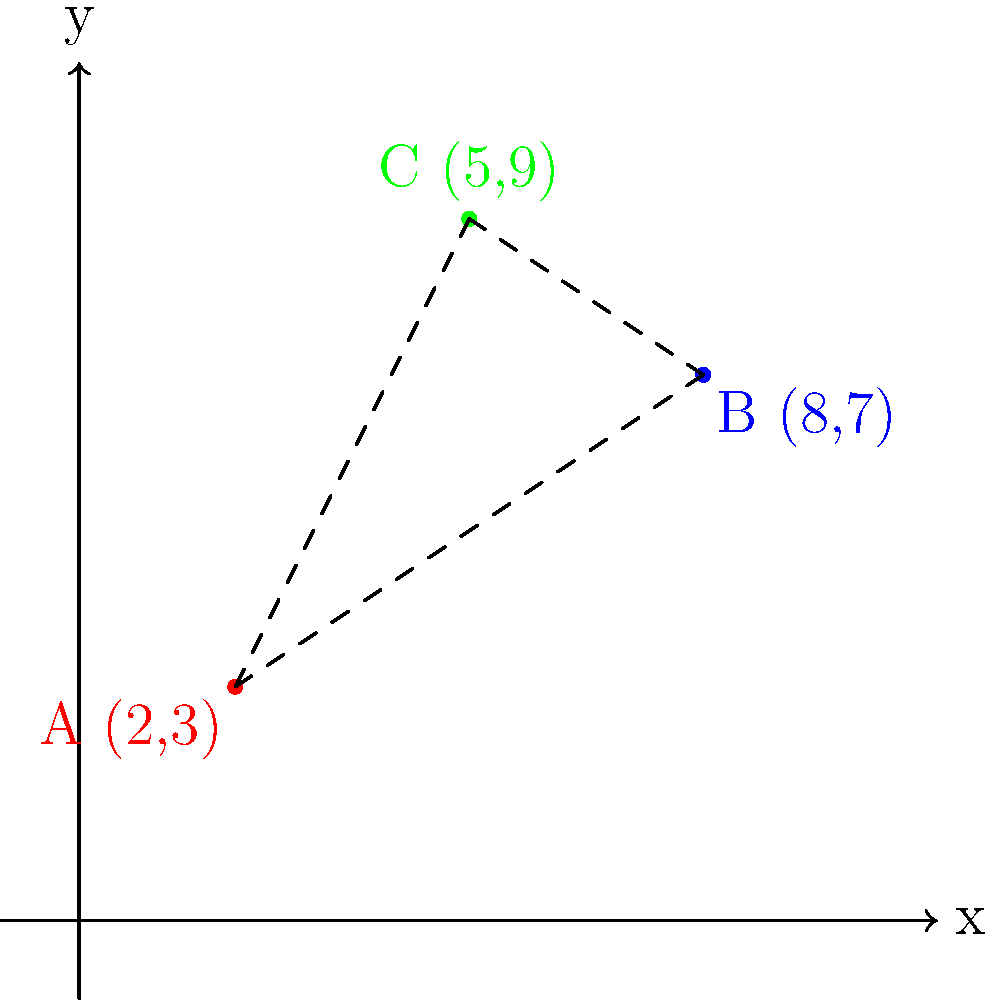In a gene cluster analysis, three distinct clusters A, B, and C are represented as points in a 2D space. Their coordinates are A(2,3), B(8,7), and C(5,9). Calculate the perimeter of the triangle formed by these three gene clusters. Round your answer to two decimal places. To find the perimeter of the triangle, we need to calculate the distances between each pair of points and sum them up. We'll use the distance formula:

Distance = $$\sqrt{(x_2-x_1)^2 + (y_2-y_1)^2}$$

Step 1: Calculate distance AB
$$AB = \sqrt{(8-2)^2 + (7-3)^2} = \sqrt{36 + 16} = \sqrt{52} \approx 7.21$$

Step 2: Calculate distance BC
$$BC = \sqrt{(5-8)^2 + (9-7)^2} = \sqrt{9 + 4} = \sqrt{13} \approx 3.61$$

Step 3: Calculate distance CA
$$CA = \sqrt{(2-5)^2 + (3-9)^2} = \sqrt{9 + 36} = \sqrt{45} \approx 6.71$$

Step 4: Sum up the distances to get the perimeter
Perimeter = AB + BC + CA ≈ 7.21 + 3.61 + 6.71 = 17.53

Rounding to two decimal places, we get 17.53.
Answer: 17.53 